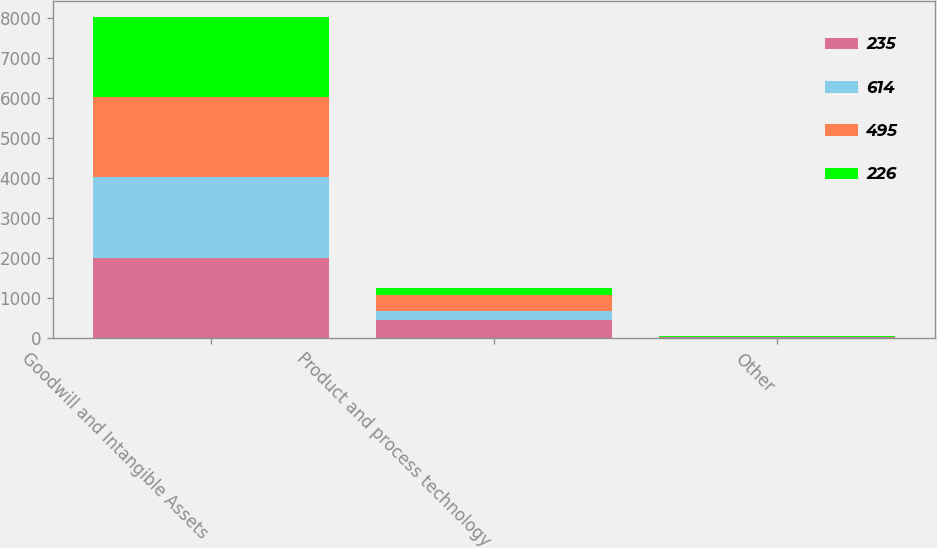<chart> <loc_0><loc_0><loc_500><loc_500><stacked_bar_chart><ecel><fcel>Goodwill and Intangible Assets<fcel>Product and process technology<fcel>Other<nl><fcel>235<fcel>2006<fcel>460<fcel>27<nl><fcel>614<fcel>2006<fcel>219<fcel>3<nl><fcel>495<fcel>2005<fcel>385<fcel>5<nl><fcel>226<fcel>2005<fcel>178<fcel>2<nl></chart> 